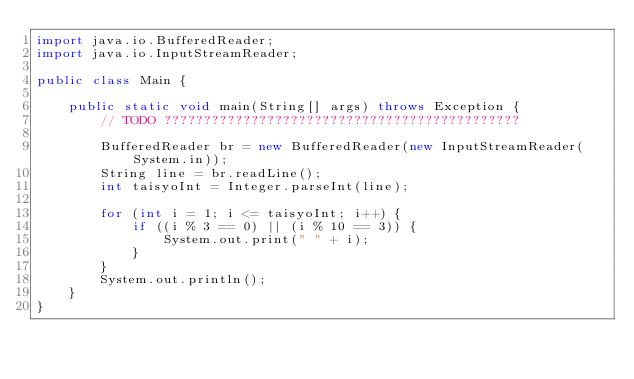Convert code to text. <code><loc_0><loc_0><loc_500><loc_500><_Java_>import java.io.BufferedReader;
import java.io.InputStreamReader;

public class Main {

	public static void main(String[] args) throws Exception {
		// TODO ?????????????????????????????????????????????

		BufferedReader br = new BufferedReader(new InputStreamReader(System.in));
		String line = br.readLine();
		int taisyoInt = Integer.parseInt(line);

		for (int i = 1; i <= taisyoInt; i++) {
			if ((i % 3 == 0) || (i % 10 == 3)) {
				System.out.print(" " + i);
			}
		}
		System.out.println();
	}
}</code> 